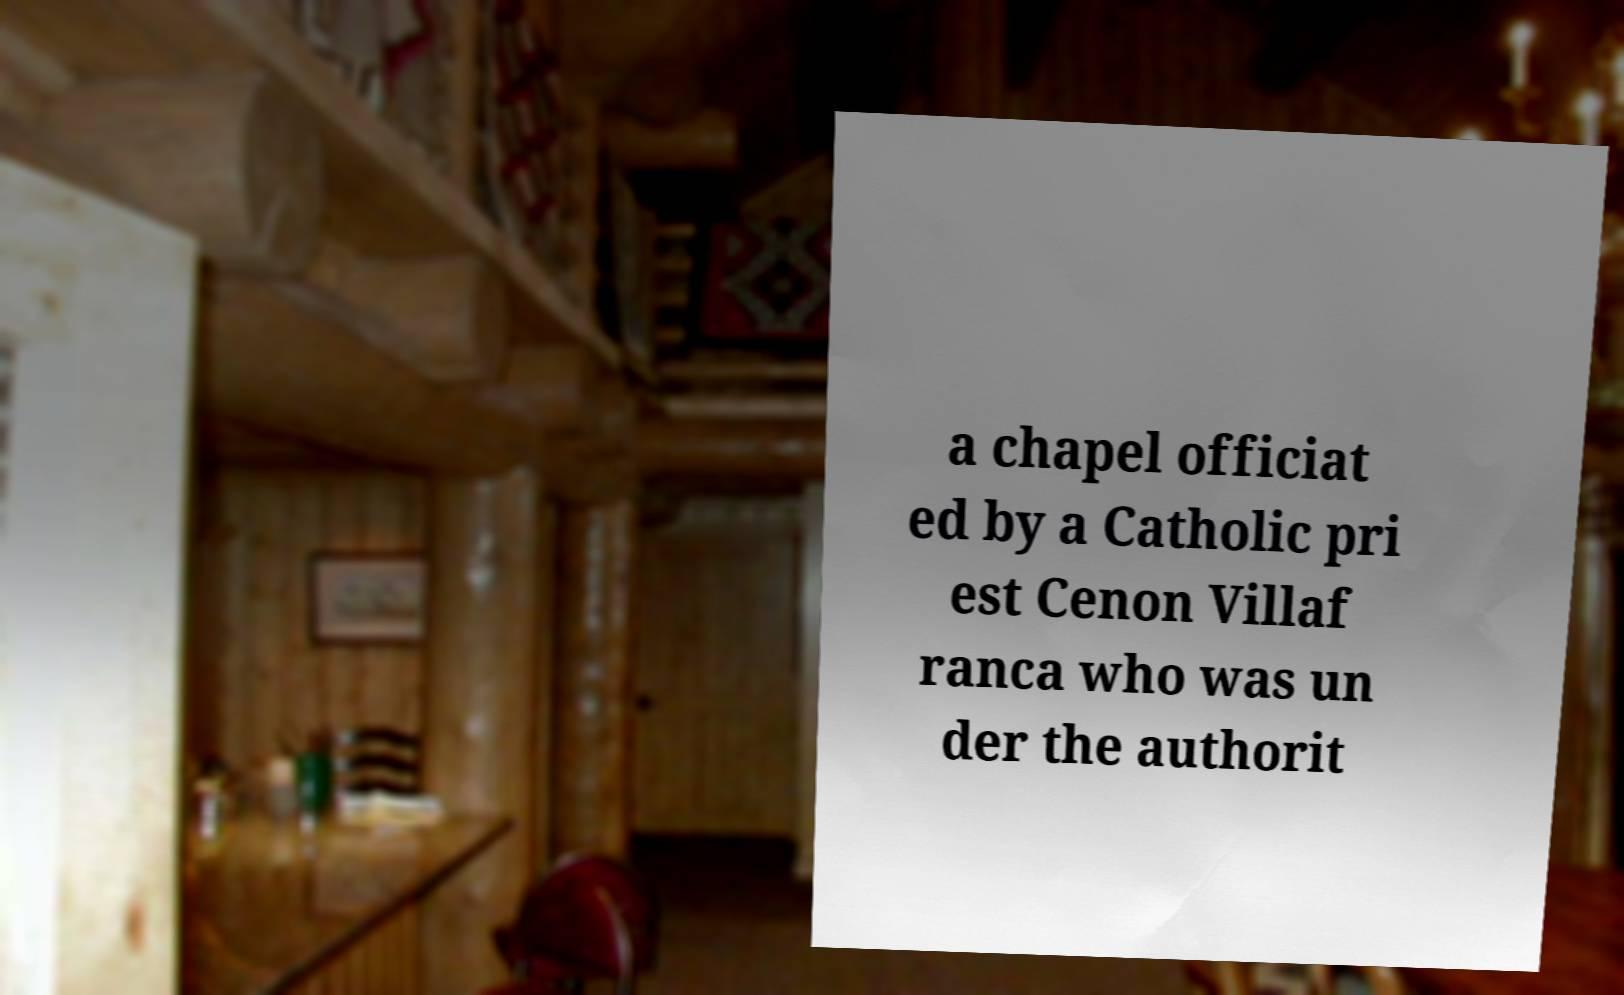Can you accurately transcribe the text from the provided image for me? a chapel officiat ed by a Catholic pri est Cenon Villaf ranca who was un der the authorit 